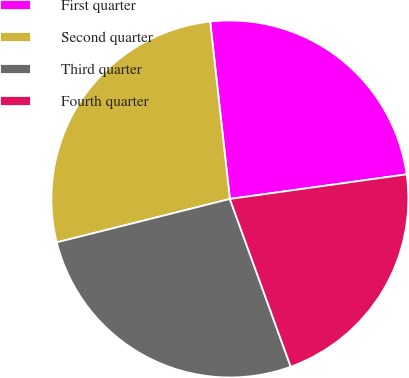Convert chart. <chart><loc_0><loc_0><loc_500><loc_500><pie_chart><fcel>First quarter<fcel>Second quarter<fcel>Third quarter<fcel>Fourth quarter<nl><fcel>24.56%<fcel>27.15%<fcel>26.63%<fcel>21.66%<nl></chart> 